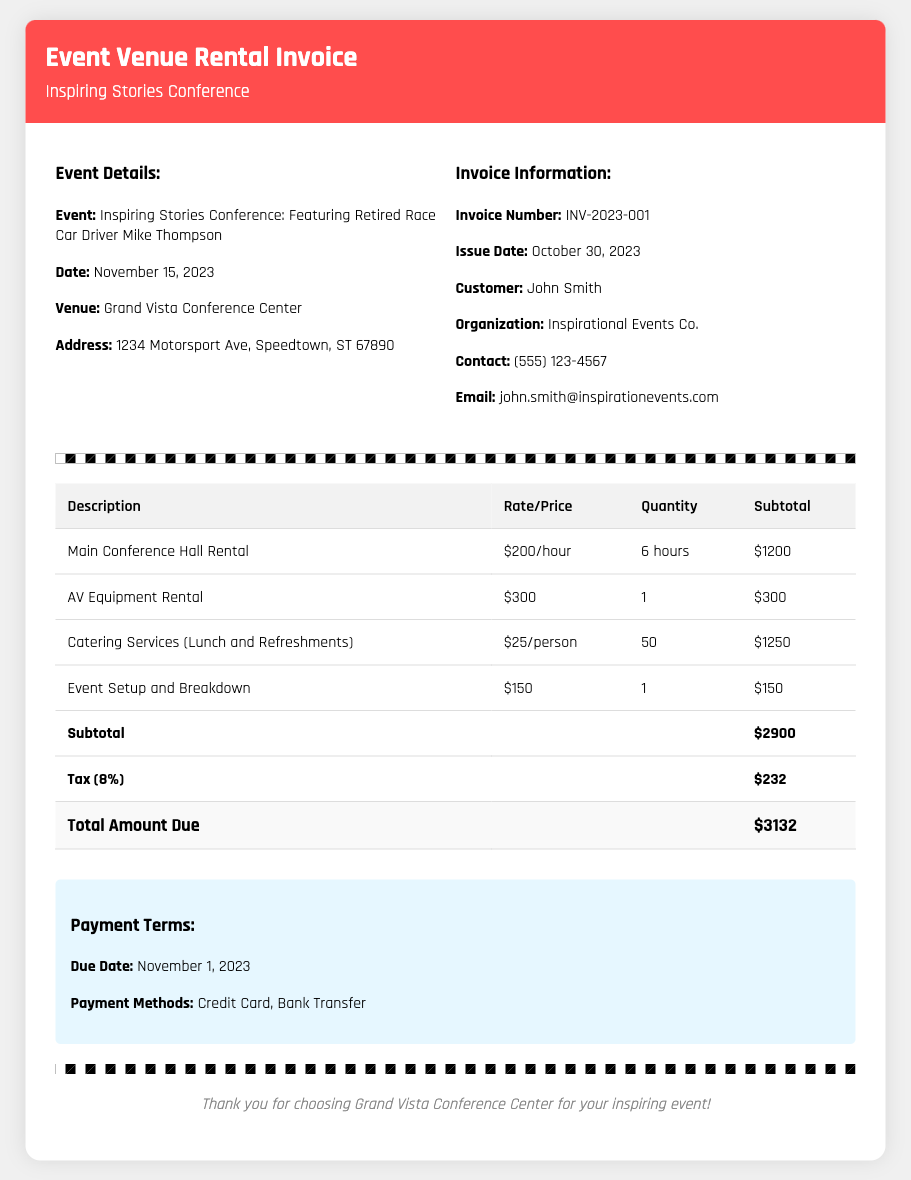What is the invoice number? The invoice number is a specific identifier provided in the document for reference.
Answer: INV-2023-001 What is the total amount due? The total amount due is the final charge that includes services, taxes, and any additional fees reflected in the document.
Answer: $3132 What is the date of the event? The date of the event is critical information that indicates when the conference featuring the retired race car driver will be held.
Answer: November 15, 2023 What is the hourly rate for the main conference hall rental? The hourly rate is the cost per hour to rent the main conference hall, which is specified in the document.
Answer: $200/hour How many attendees are catered for the conference? The number of attendees is vital for calculating catering costs, as indicated in the document.
Answer: 50 What is the total catering cost? The total catering cost is calculated based on the price per person and the number of attendees.
Answer: $1250 What is the tax rate applied in this invoice? The tax rate is essential to understand how the final total is calculated from the subtotal.
Answer: 8% What payment methods are accepted? Payment methods indicate how the customer can settle the invoice and are listed explicitly in the document.
Answer: Credit Card, Bank Transfer What is the address of the venue? The venue address provides the location details necessary for event planning and attendance.
Answer: 1234 Motorsport Ave, Speedtown, ST 67890 